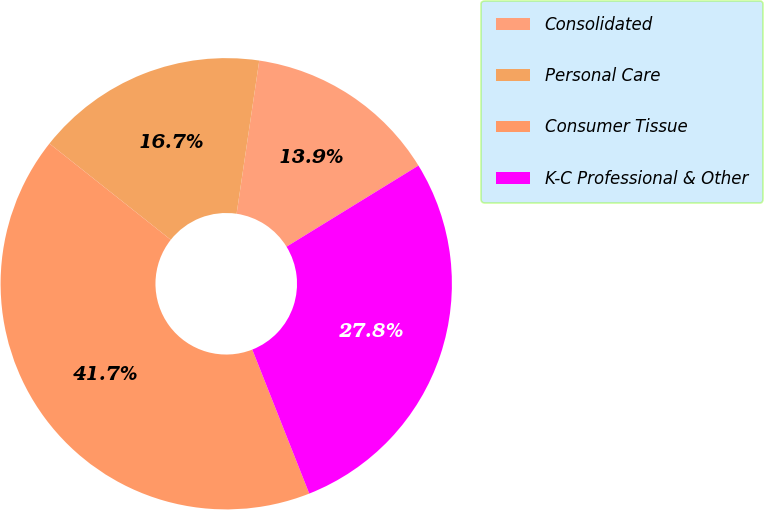Convert chart. <chart><loc_0><loc_0><loc_500><loc_500><pie_chart><fcel>Consolidated<fcel>Personal Care<fcel>Consumer Tissue<fcel>K-C Professional & Other<nl><fcel>13.89%<fcel>16.67%<fcel>41.67%<fcel>27.78%<nl></chart> 